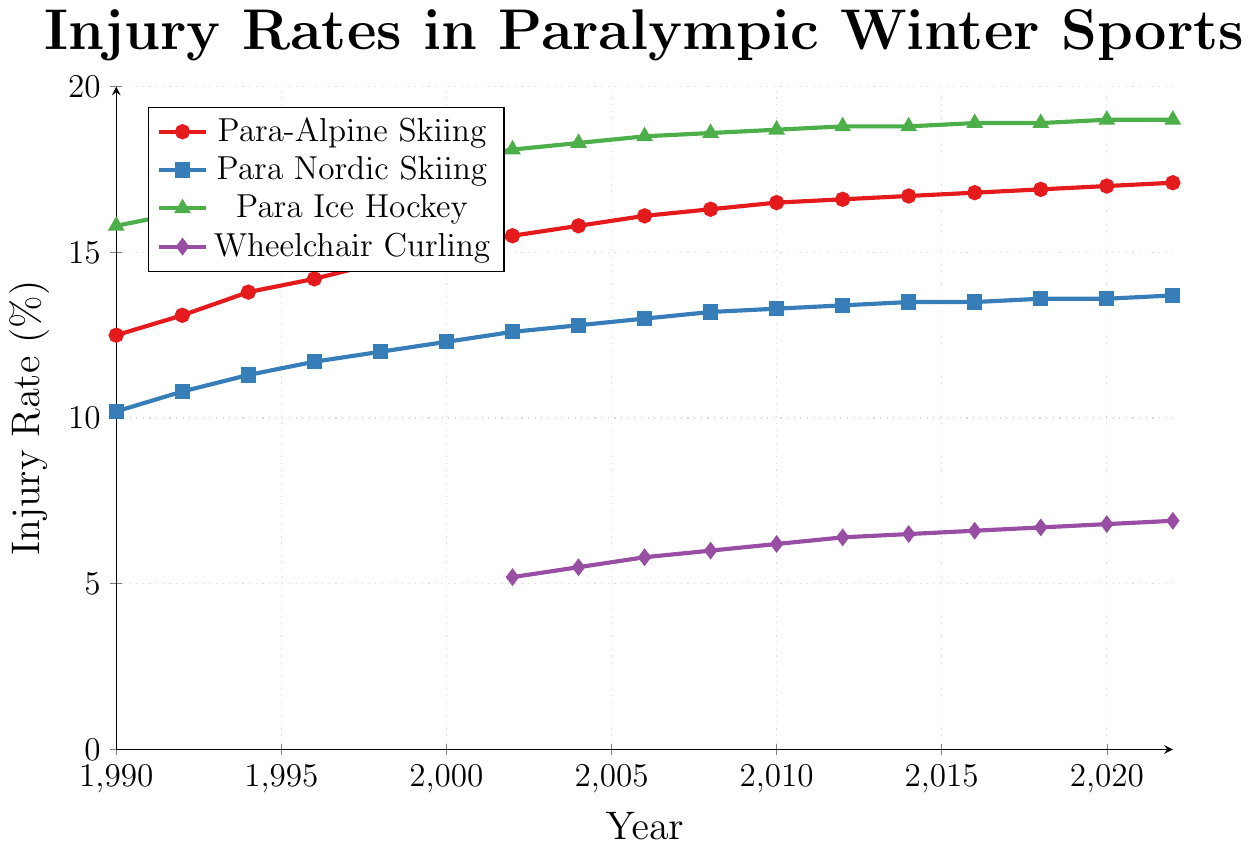What sport has the highest injury rate in 1990? Look for the data point in 1990 across all sports and identify the sport with the highest value.
Answer: Para Ice Hockey How did the injury rate for Para Nordic Skiing change from 1990 to 2022? Calculate the difference between the injury rate for Para Nordic Skiing in 2022 and 1990.
Answer: Increased by 3.5% Which sport had the largest increase in injury rates from 1990 to 2022? Calculate the difference in injury rates from 1990 to 2022 for each sport and compare them.
Answer: Para-Alpine Skiing What is the color associated with Wheelchair Curling in the plot? Look at the legend to find the color that represents Wheelchair Curling.
Answer: Purple Between Para-Alpine Skiing and Para Ice Hockey, which sport had a higher injury rate in 2014? Look at the injury rates in 2014 for both Para-Alpine Skiing and Para Ice Hockey and compare them.
Answer: Para Ice Hockey What is the average injury rate for Para-Alpine Skiing from 1990 to 2022? Sum the injury rates for Para-Alpine Skiing from 1990 to 2022 and divide by the number of years. Calculate step-by-step: sum = 12.5 + 13.1 + 13.8 + 14.2 + 14.7 + 15.1 + 15.5 + 15.8 + 16.1 + 16.3 + 16.5 + 16.6 + 16.7 + 16.8 + 16.9 + 17.0 + 17.1 = 261.8. Then divide by 17 years.
Answer: 15.4% Did Wheelchair Curling ever reach an injury rate above 7% within its recorded years? Look at the displayed data points for Wheelchair Curling and check if any point exceeds 7%.
Answer: No In what year did Para Nordic Skiing reach an injury rate of exactly 13%? Find the year on the x-axis that aligns with the y-axis value of 13% for Para Nordic Skiing.
Answer: 2006 Which sport showed the least variability in injury rates from 1990 to 2022? Compare the differences in injury rates over the years for each sport and identify the one with the smallest range.
Answer: Para Nordic Skiing What is the injury rate difference between Para Alpine Skiing and Wheelchair Curling in 2022? Subtract the injury rate of Wheelchair Curling in 2022 from that of Para Alpine Skiing in the same year.
Answer: 10.2% 